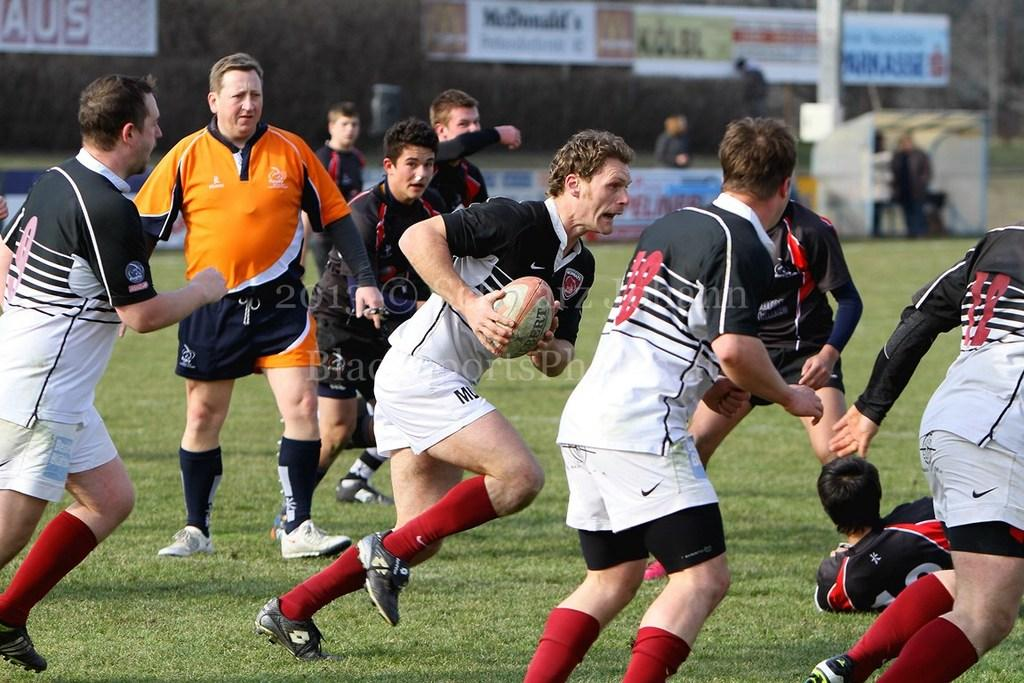What activity are the people in the image engaged in? The group of people are playing American football. What can be seen in the background of the image? There are boards and a pillar in the background of the image. Is there any additional information about the image itself? Yes, there is a watermark on the image. What type of debt is being discussed by the people playing American football in the image? There is no discussion of debt in the image; the people are playing American football. Can you describe the alley where the American football game is taking place in the image? There is no alley present in the image; it is an open area where the game is being played. 